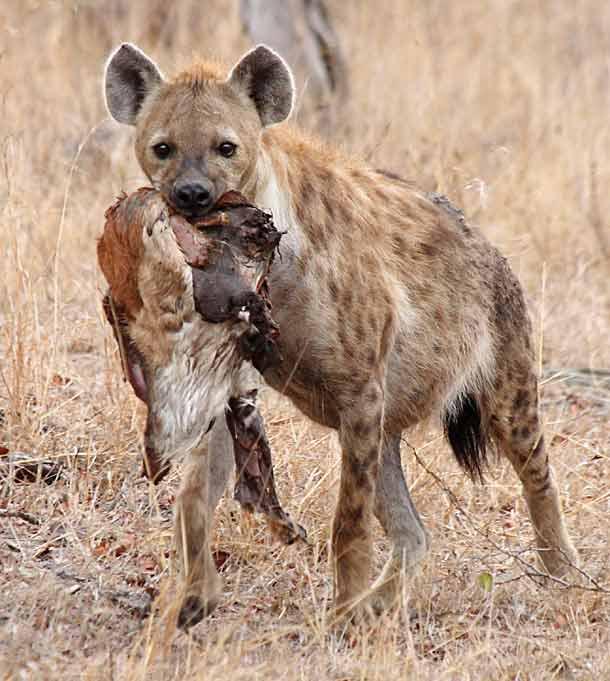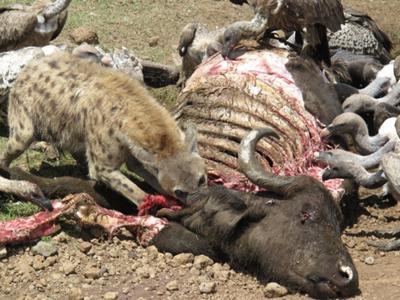The first image is the image on the left, the second image is the image on the right. Analyze the images presented: Is the assertion "The right image includes at least one leftward-facing hyena standing in front of a large rock, but does not include a carcass or any other type of animal in the foreground." valid? Answer yes or no. No. The first image is the image on the left, the second image is the image on the right. For the images shown, is this caption "In at least one image there is a single hyena with its mouth facing the dead prey." true? Answer yes or no. Yes. 